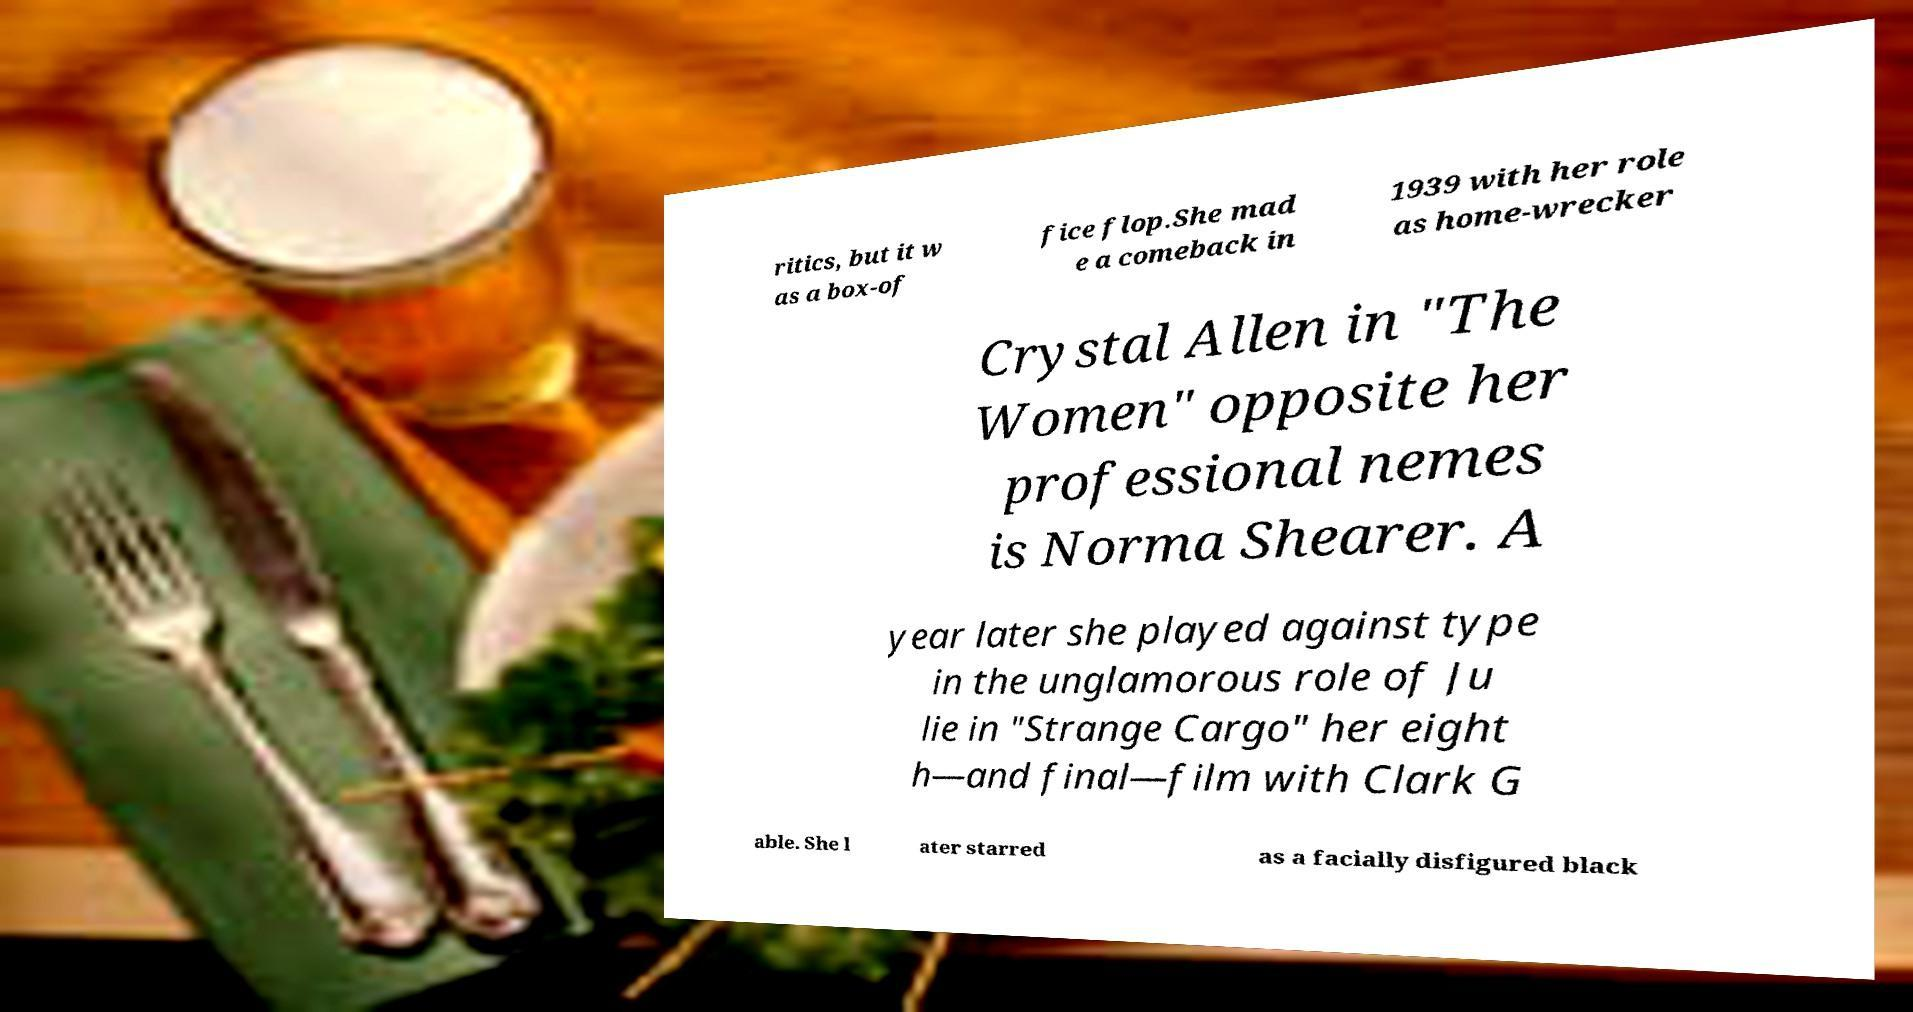Please identify and transcribe the text found in this image. ritics, but it w as a box-of fice flop.She mad e a comeback in 1939 with her role as home-wrecker Crystal Allen in "The Women" opposite her professional nemes is Norma Shearer. A year later she played against type in the unglamorous role of Ju lie in "Strange Cargo" her eight h—and final—film with Clark G able. She l ater starred as a facially disfigured black 